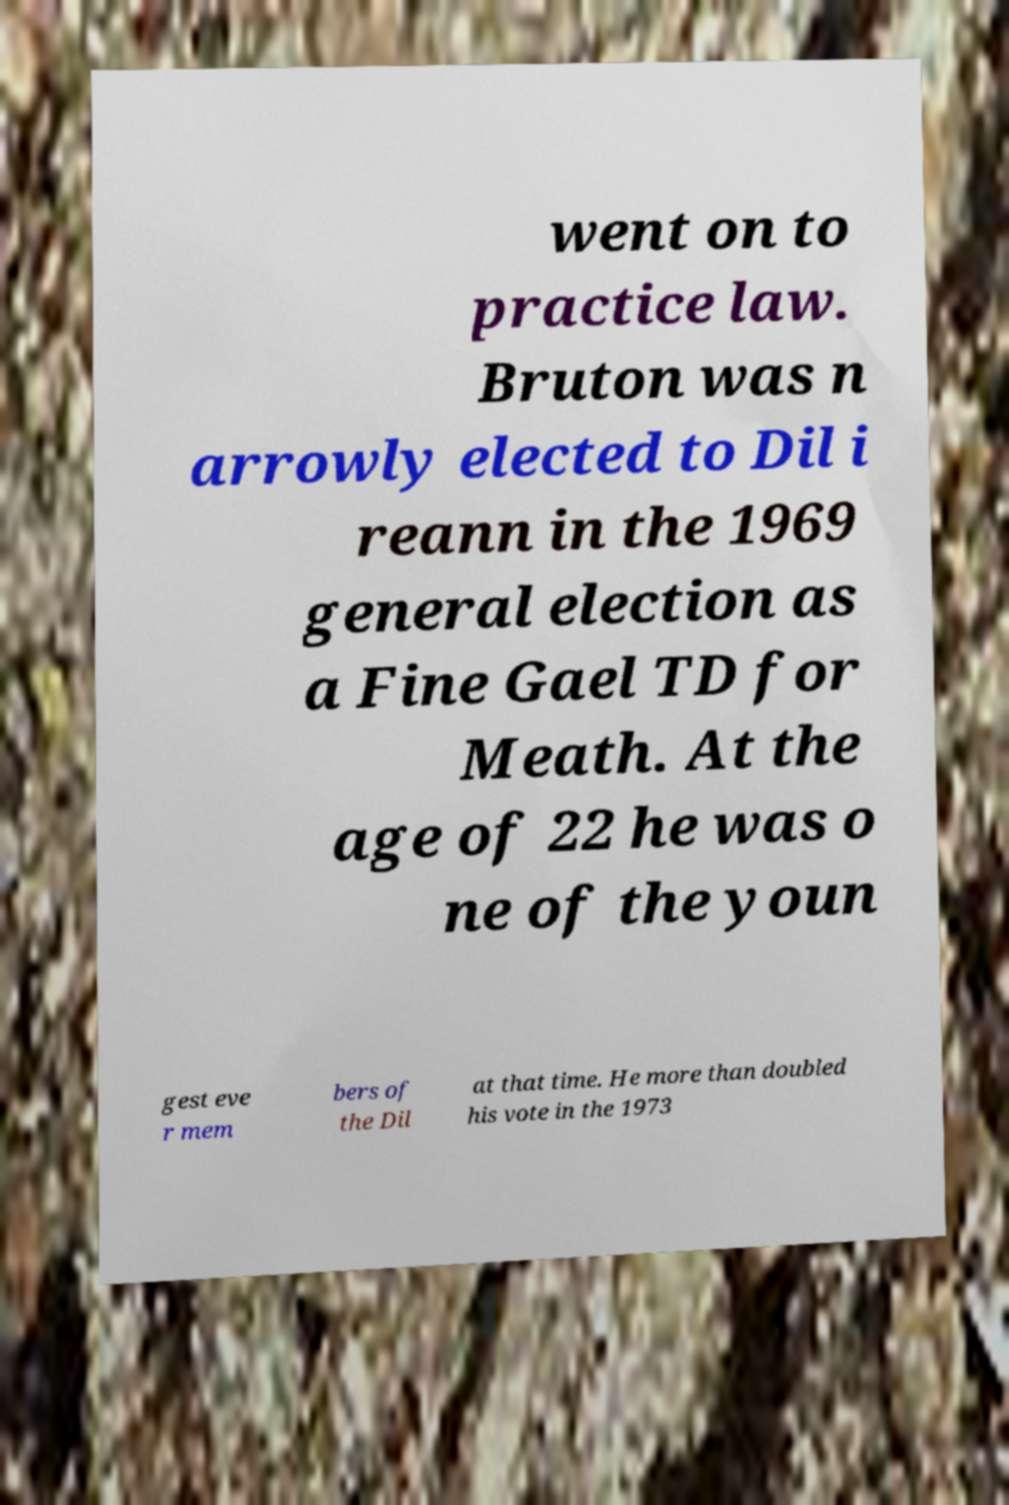Could you assist in decoding the text presented in this image and type it out clearly? went on to practice law. Bruton was n arrowly elected to Dil i reann in the 1969 general election as a Fine Gael TD for Meath. At the age of 22 he was o ne of the youn gest eve r mem bers of the Dil at that time. He more than doubled his vote in the 1973 